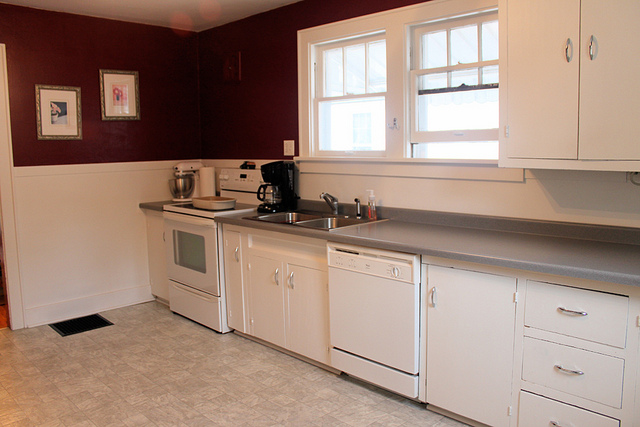What color are the walls in this kitchen? The walls in the kitchen are painted a deep burgundy or maroon color, adding a rich and warm feel to the room. 